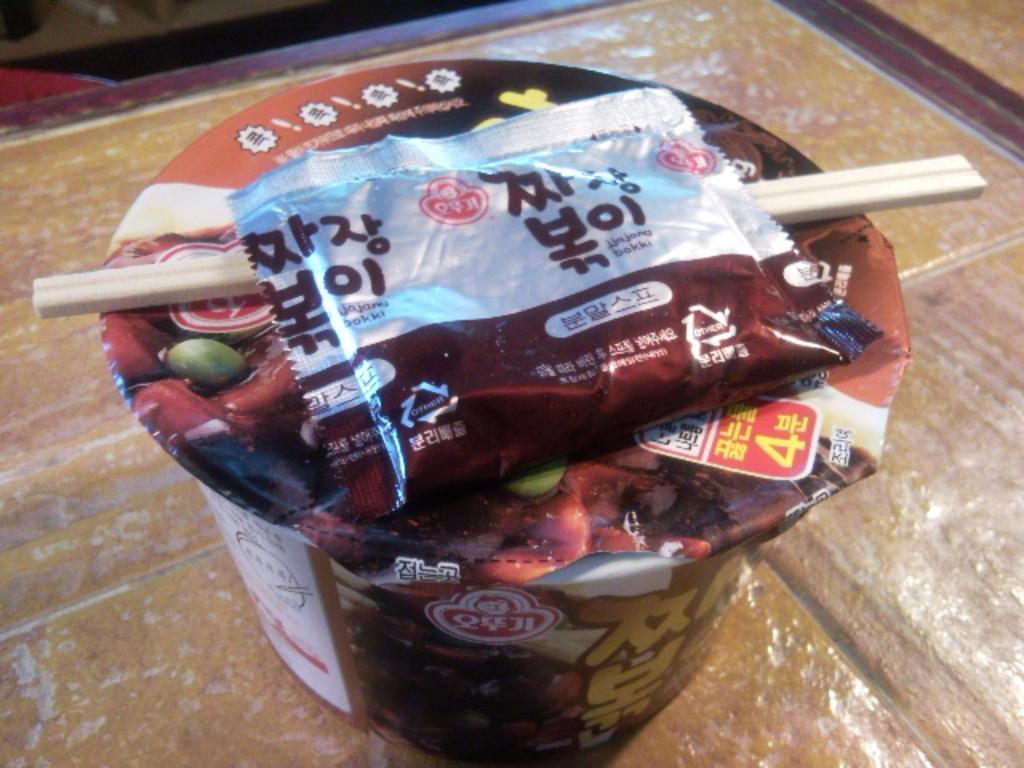Describe this image in one or two sentences. It is a food item cup in brown color. 